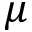Convert formula to latex. <formula><loc_0><loc_0><loc_500><loc_500>\mu</formula> 